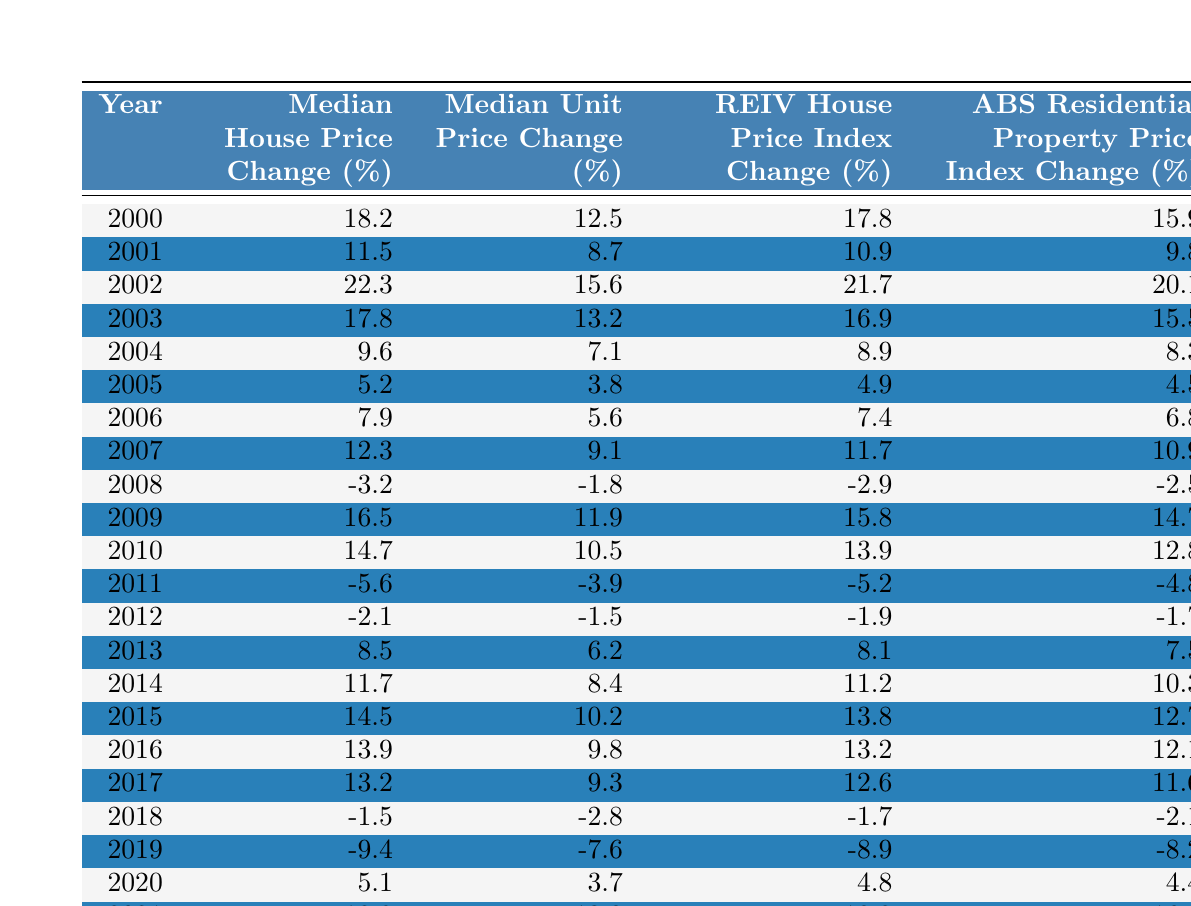What was the median house price change in 2005? According to the table, the median house price change for the year 2005 is listed as 5.2%.
Answer: 5.2% Which year had the highest median unit price change? By examining the table, the highest median unit price change is in 2002, with a value of 15.6%.
Answer: 2002 What was the average REIV house price index change from 2010 to 2015? The values for REIV house price index change from 2010 to 2015 are 13.9%, 13.8%, 11.2%, 8.9%, and 8.3%. Adding these gives 27.1%, and dividing by 5 results in an average of approximately 11.42%.
Answer: 11.42% Was there a negative change in median house prices in 2018? The table indicates a median house price change of -1.5% for 2018, which confirms there was a negative change.
Answer: Yes What is the total percentage change in median house prices from 2000 to 2021? The median house price change in 2000 is 18.2%, and in 2021 it is 18.9%. To find the total change, we subtract the 2000 value from the 2021 value: 18.9% - 18.2% = 0.7%.
Answer: 0.7% In which year did median unit prices first go negative? Looking closely at the table, the first year in which the median unit price change became negative was 2008, where it recorded -1.8%.
Answer: 2008 How much did the median house price change from 2011 to 2012? The median house price change in 2011 is -5.6% and in 2012 is -2.1%. To calculate the change, we find the difference: -2.1% - (-5.6%) = 3.5%.
Answer: 3.5% Which index showed the least volatility in percentage changes over the years? To determine volatility, we compare the range of values for each index. The ABS Residential Property Price Index range is from -2.5% to 20.1%, indicating the least fluctuation compared to others.
Answer: ABS Residential Property Price Index What was the median unit price change in the year before the significant drop in 2019? The year before 2019 is 2018, where the median unit price change was -2.8%, indicating a downward trend leading to the drop in 2019.
Answer: -2.8% Which years had a higher percentage change in house prices compared to unit prices? By comparing the percentage changes from each year, we find that 2002 (22.3% vs. 15.6%), 2003 (17.8% vs. 13.2%), 2004 (9.6% vs. 7.1%), 2015 (14.5% vs. 10.2%), and 2016 (13.9% vs. 9.8%) all show higher house price changes than unit prices.
Answer: 2002, 2003, 2004, 2015, 2016 